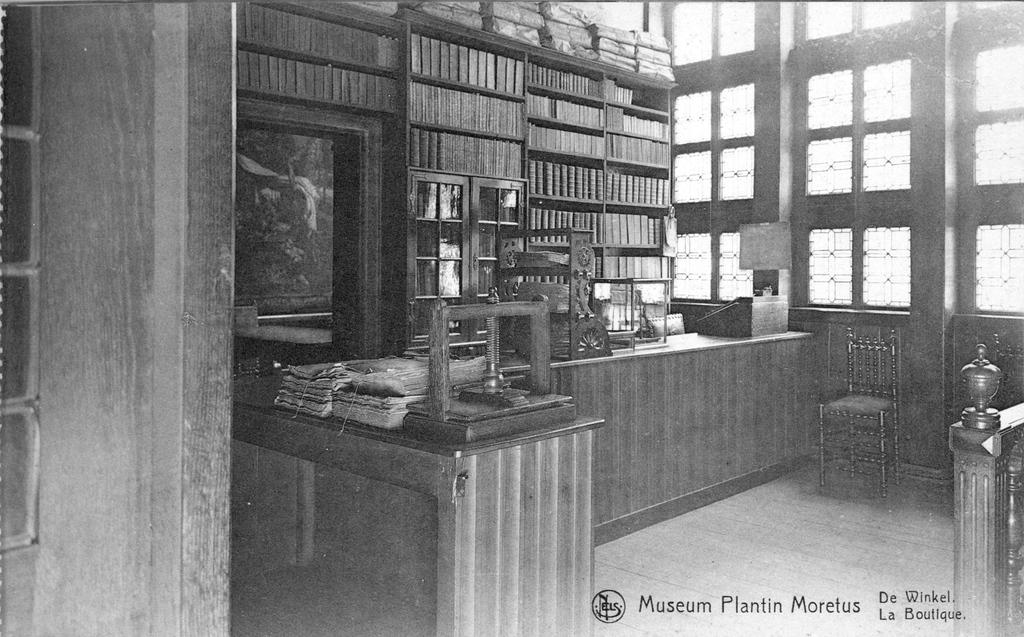<image>
Offer a succinct explanation of the picture presented. a black and white post card of the museum plantin moletus 